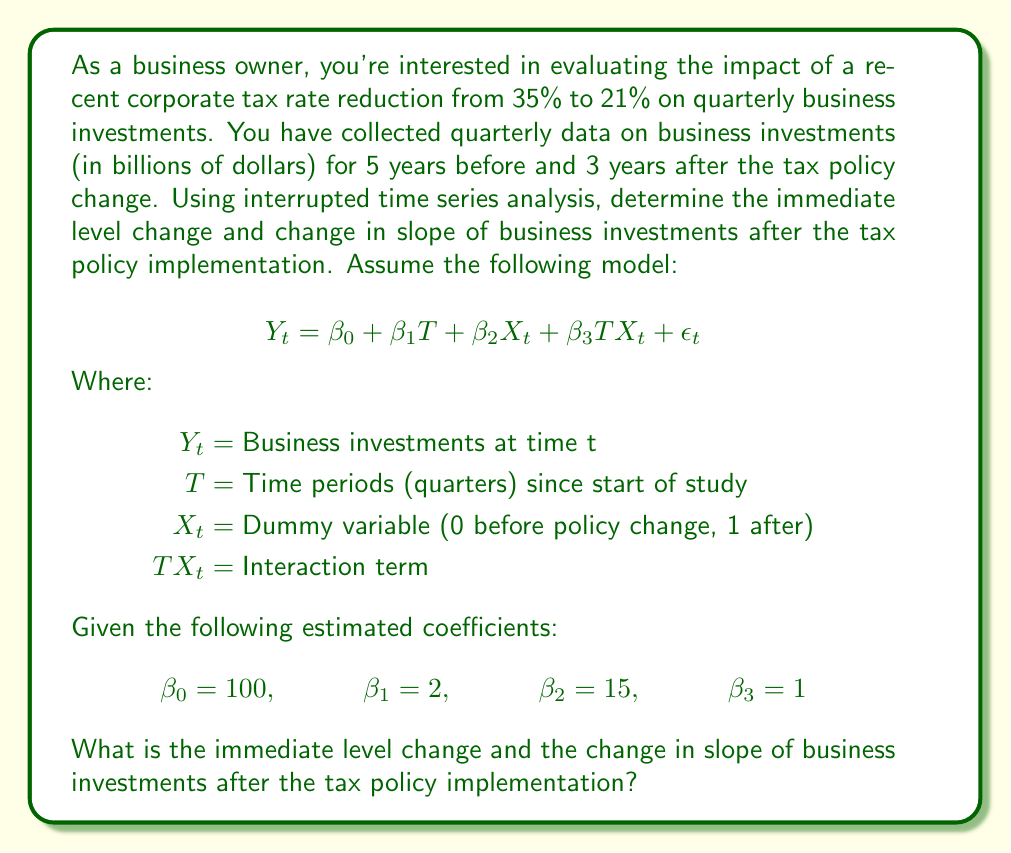Solve this math problem. To solve this problem, we need to interpret the coefficients of the interrupted time series model:

1. Immediate level change:
   The immediate level change is represented by $\beta_2$, which is the coefficient of the dummy variable $X_t$. This shows the immediate jump (or drop) in the outcome variable right after the intervention.

   In this case, $\beta_2 = 15$, indicating an immediate increase of $15 billion in business investments right after the tax policy change.

2. Change in slope:
   The change in slope is represented by $\beta_3$, which is the coefficient of the interaction term $TX_t$. This shows how the trend (slope) of the outcome variable changes after the intervention.

   In this case, $\beta_3 = 1$, indicating that the slope of business investments increased by $1 billion per quarter after the tax policy change.

To interpret this in context:

- Before the tax policy change, the trend in business investments was increasing by $\beta_1 = 2$ billion per quarter.
- Immediately after the tax policy change, there was a jump of $\beta_2 = 15$ billion in business investments.
- After the tax policy change, the trend in business investments is now increasing by $\beta_1 + \beta_3 = 2 + 1 = 3$ billion per quarter.

This analysis suggests that the tax policy change had both an immediate positive effect on business investments and accelerated the growth rate of investments over time.
Answer: The immediate level change in business investments after the tax policy implementation is an increase of $15 billion, and the change in slope is an increase of $1 billion per quarter. 